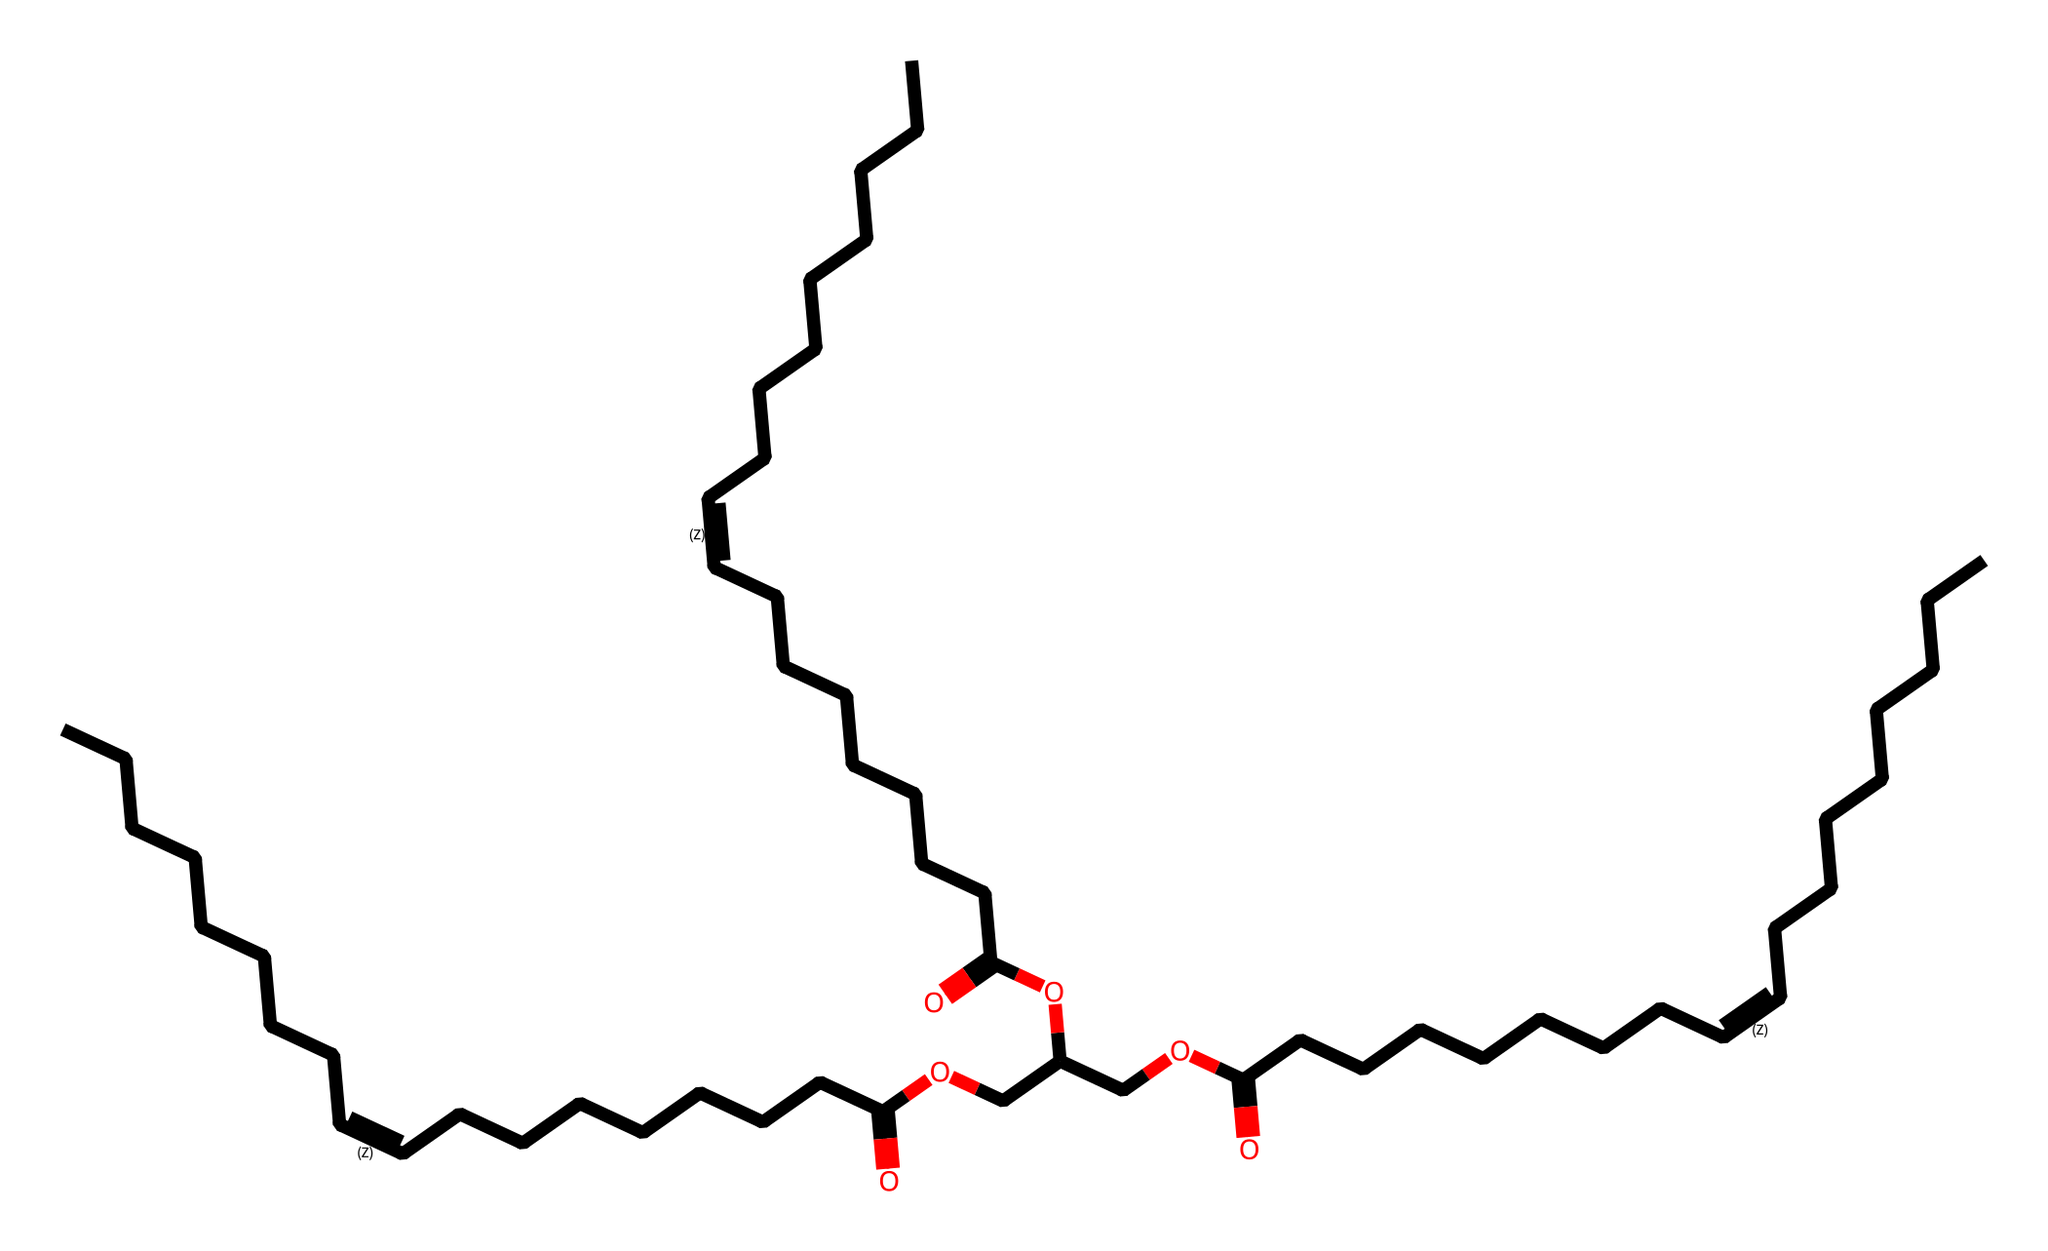what type of functional group is present in this chemical? The structure contains a carboxylic acid group, identified by the presence of the -COOH functional group. This is evidenced by the carbon atom double-bonded to an oxygen atom and single-bonded to a hydroxyl group (-OH).
Answer: carboxylic acid how many carbon atoms are present in this molecule? By analyzing the SMILES representation, you can count the number of 'C' characters, which represent carbon atoms. In total, there are 36 carbon atoms reflected in the sequence.
Answer: 36 is this chemical saturated or unsaturated? The presence of double bonds, indicated by the "/C=C\" in the SMILES structure, shows that this chemical has unsaturated bonds, confirming it is an unsaturated compound.
Answer: unsaturated how many ester linkages are found in this chemical? The chemical structure contains multiple ester linkages, which can be identified by the occurrences of -O- bonded to carbonyl groups (C=O). In this case, there are three ester linkages present.
Answer: three what is the primary application of this chemical in cooking? This chemical structure likely represents a cooking oil, which is typically utilized as a fat source for frying and enhancing flavors in food preparation, especially in fast food contexts.
Answer: cooking oil what is the predominant type of bond in this chemical structure? The predominant type of bond in this molecule is covalent bonds. These bonds primarily form between carbon and oxygen atoms in various functional groups, characteristic of organic compounds.
Answer: covalent how does the presence of double bonds affect the properties of this liquid? The presence of double bonds typically lowers the melting point and increases the fluidity of the liquid. It influences the oil's stability and dietary properties, suggesting potential health implications when used in cooking.
Answer: lowers melting point 